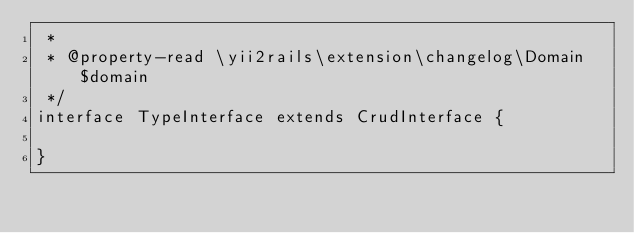<code> <loc_0><loc_0><loc_500><loc_500><_PHP_> * 
 * @property-read \yii2rails\extension\changelog\Domain $domain
 */
interface TypeInterface extends CrudInterface {

}
</code> 